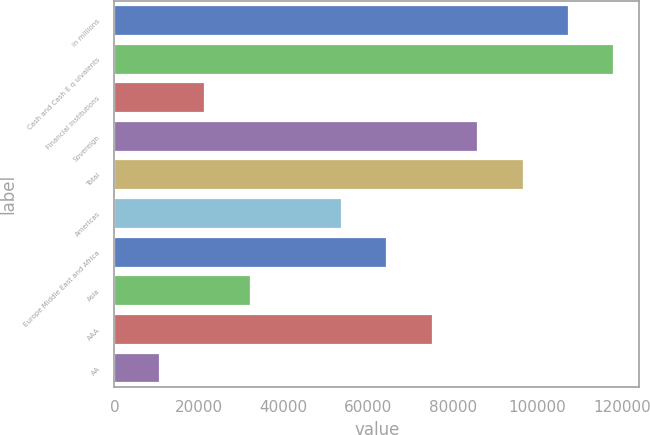Convert chart. <chart><loc_0><loc_0><loc_500><loc_500><bar_chart><fcel>in millions<fcel>Cash and Cash E q uivalents<fcel>Financial Institutions<fcel>Sovereign<fcel>Total<fcel>Americas<fcel>Europe Middle East and Africa<fcel>Asia<fcel>AAA<fcel>AA<nl><fcel>107408<fcel>118149<fcel>21482.4<fcel>85926.6<fcel>96667.3<fcel>53704.5<fcel>64445.2<fcel>32223.1<fcel>75185.9<fcel>10741.7<nl></chart> 